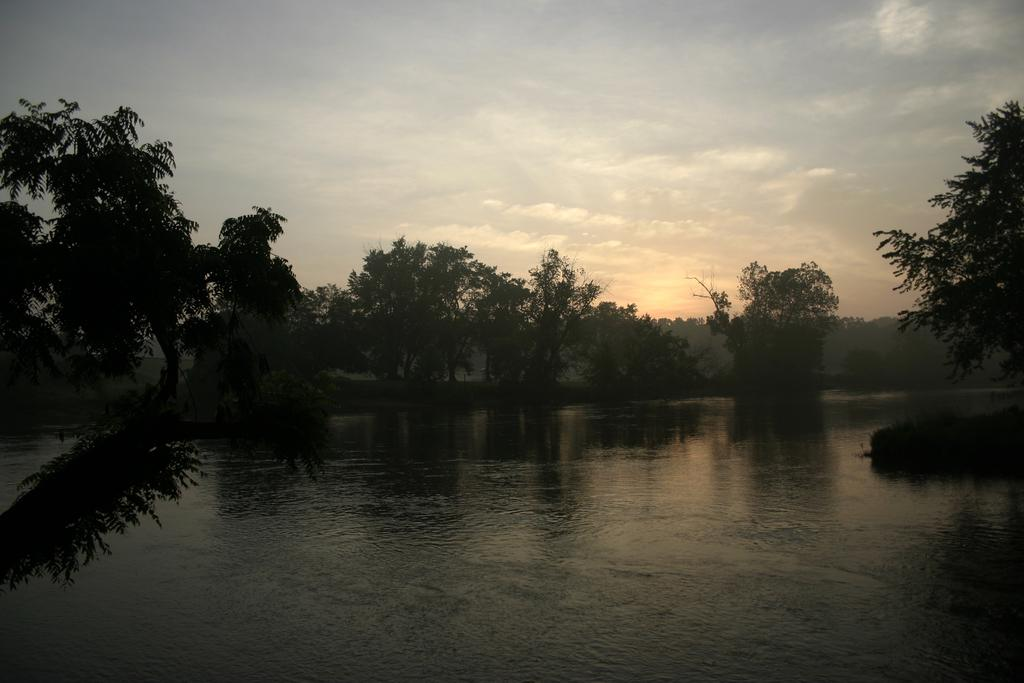What type of body of water is present in the image? There is a lake in the picture. What type of vegetation can be seen in the image? There are trees in the picture. What is the condition of the sky in the image? The sky is clear in the picture. What is the taste of the island in the picture? There is no island present in the image, so it is not possible to determine its taste. 